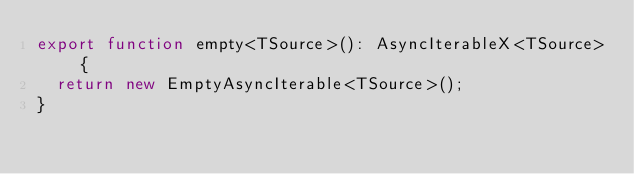<code> <loc_0><loc_0><loc_500><loc_500><_TypeScript_>export function empty<TSource>(): AsyncIterableX<TSource> {
  return new EmptyAsyncIterable<TSource>();
}
</code> 